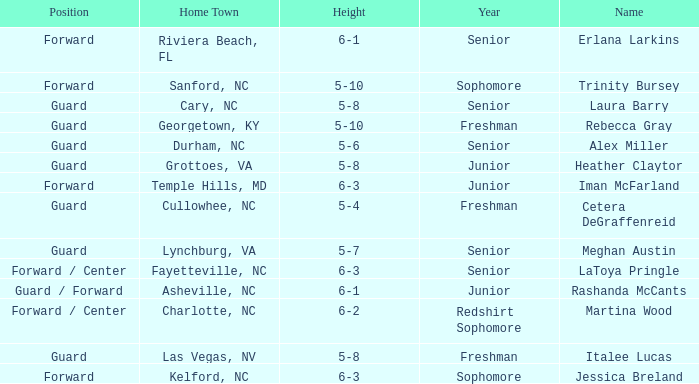In what year of school is the forward Iman McFarland? Junior. 